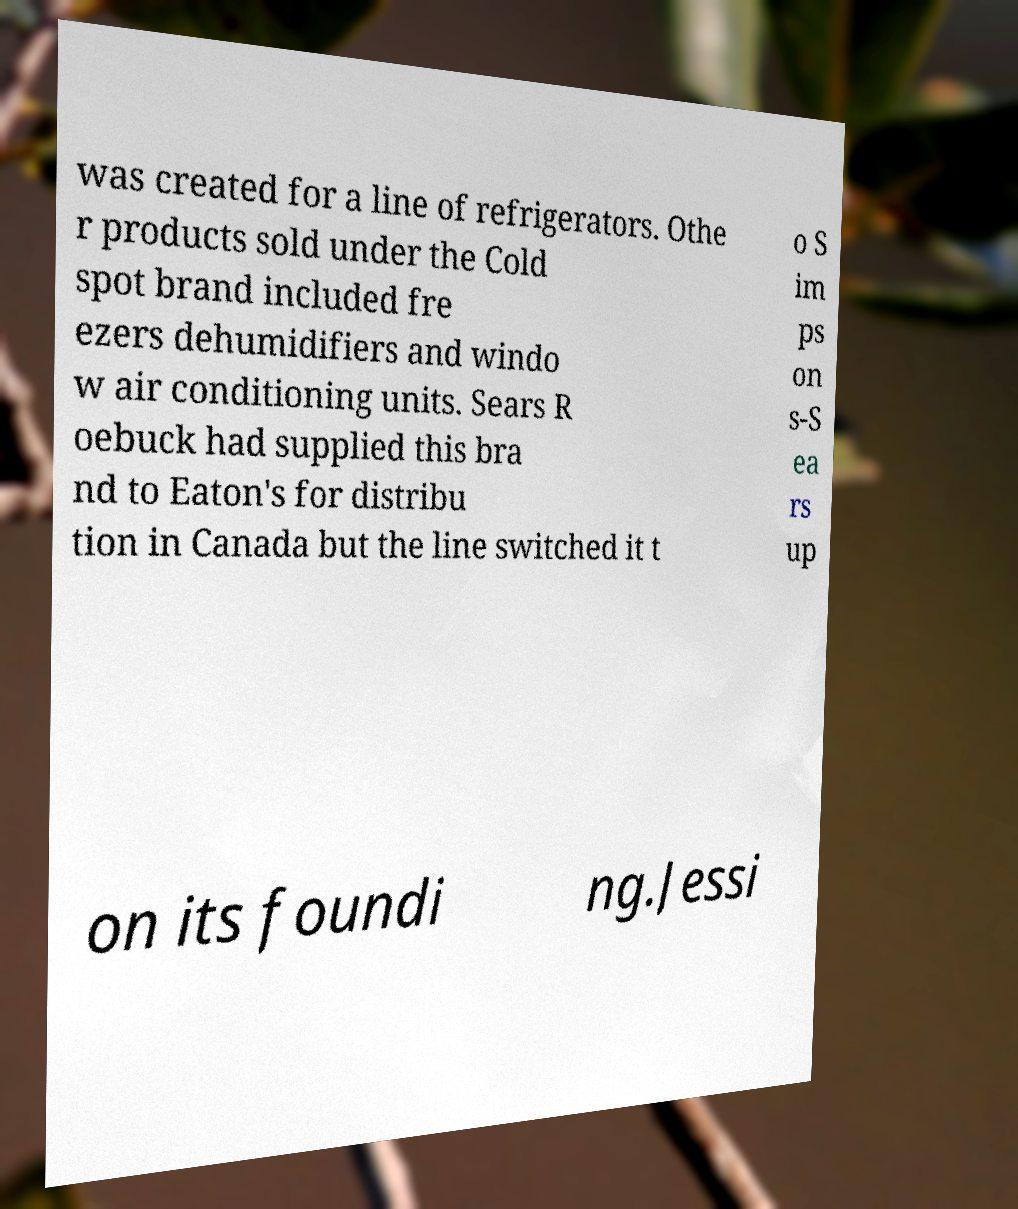Could you extract and type out the text from this image? was created for a line of refrigerators. Othe r products sold under the Cold spot brand included fre ezers dehumidifiers and windo w air conditioning units. Sears R oebuck had supplied this bra nd to Eaton's for distribu tion in Canada but the line switched it t o S im ps on s-S ea rs up on its foundi ng.Jessi 